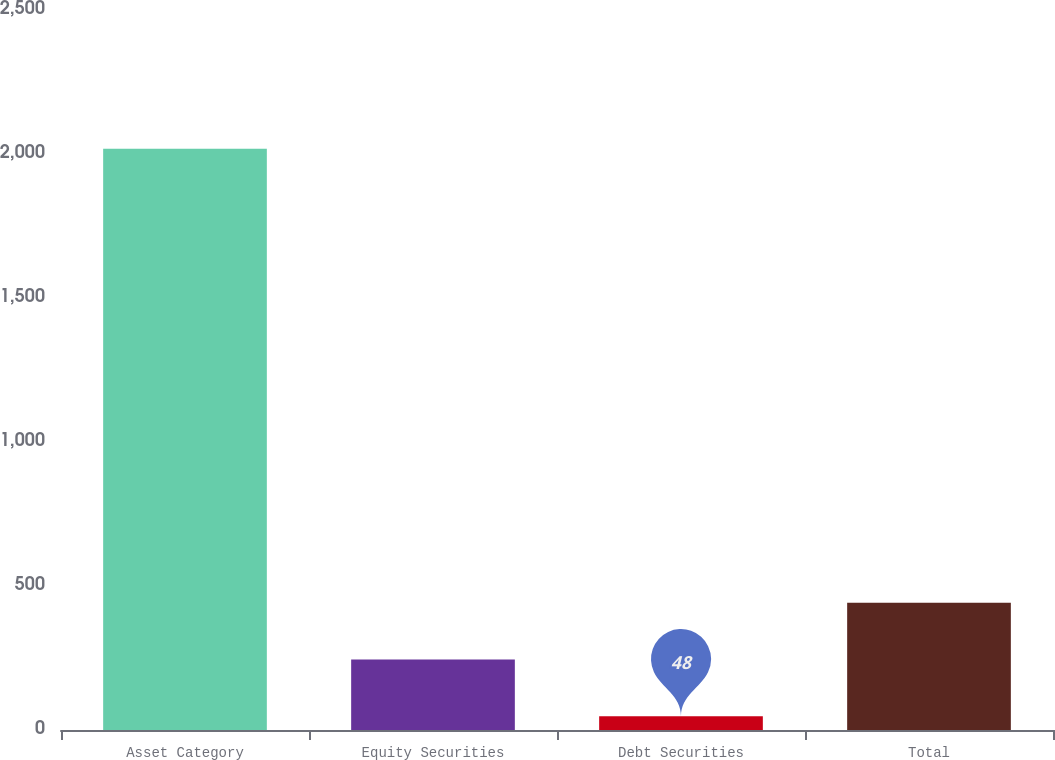Convert chart to OTSL. <chart><loc_0><loc_0><loc_500><loc_500><bar_chart><fcel>Asset Category<fcel>Equity Securities<fcel>Debt Securities<fcel>Total<nl><fcel>2018<fcel>245<fcel>48<fcel>442<nl></chart> 